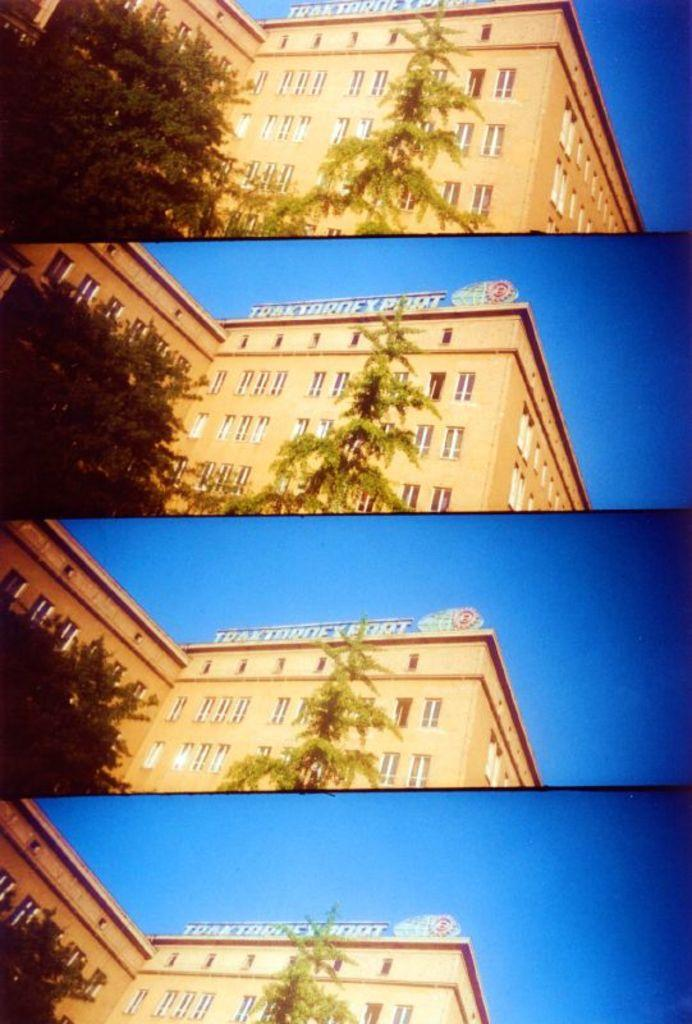What type of image is being described? The image is a collage of pictures. What is the common subject in all the pictures in the collage? All pictures in the collage contain the same building. What other elements are present in all the pictures in the collage? All pictures in the collage contain trees and the sky. What type of insurance policy is being advertised in the collage? There is no insurance policy being advertised in the collage; it consists of pictures of a building, trees, and the sky. Can you see a zipper on any of the buildings in the collage? There are no zippers visible on any of the buildings in the collage; the images only show the building's structure and surrounding elements. 